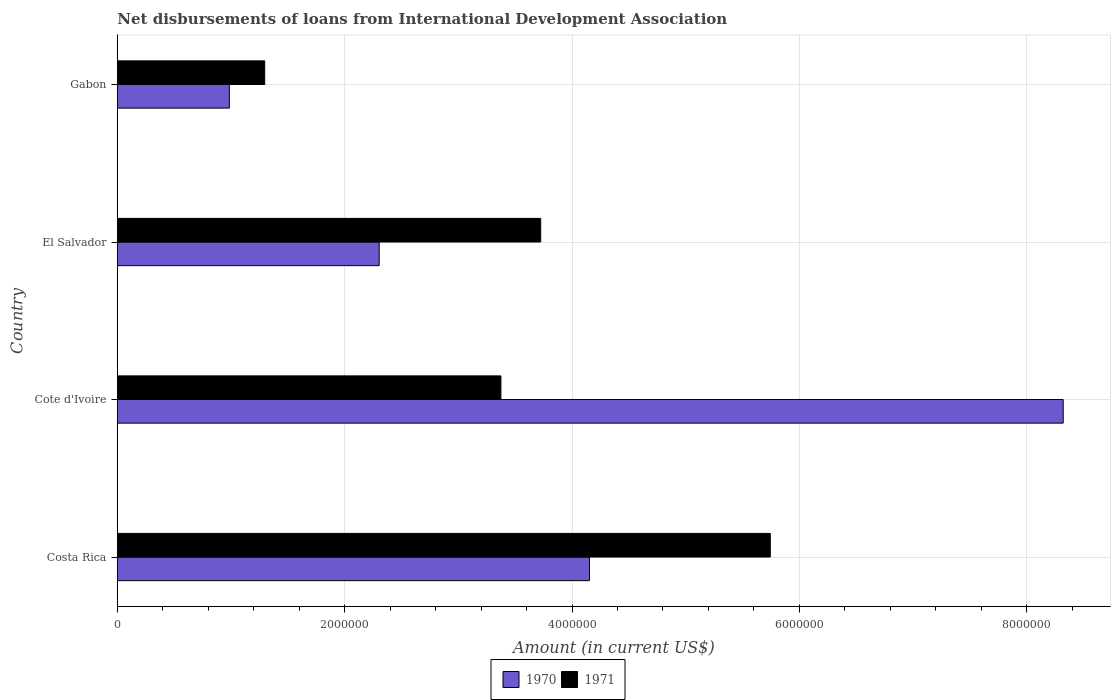How many different coloured bars are there?
Make the answer very short. 2. How many bars are there on the 1st tick from the top?
Provide a succinct answer. 2. How many bars are there on the 2nd tick from the bottom?
Provide a short and direct response. 2. In how many cases, is the number of bars for a given country not equal to the number of legend labels?
Keep it short and to the point. 0. What is the amount of loans disbursed in 1970 in Cote d'Ivoire?
Make the answer very short. 8.32e+06. Across all countries, what is the maximum amount of loans disbursed in 1970?
Your answer should be compact. 8.32e+06. Across all countries, what is the minimum amount of loans disbursed in 1970?
Ensure brevity in your answer.  9.85e+05. In which country was the amount of loans disbursed in 1970 maximum?
Give a very brief answer. Cote d'Ivoire. In which country was the amount of loans disbursed in 1971 minimum?
Make the answer very short. Gabon. What is the total amount of loans disbursed in 1970 in the graph?
Offer a very short reply. 1.58e+07. What is the difference between the amount of loans disbursed in 1970 in Cote d'Ivoire and that in Gabon?
Provide a short and direct response. 7.34e+06. What is the difference between the amount of loans disbursed in 1971 in Costa Rica and the amount of loans disbursed in 1970 in Cote d'Ivoire?
Your answer should be compact. -2.58e+06. What is the average amount of loans disbursed in 1971 per country?
Ensure brevity in your answer.  3.53e+06. What is the difference between the amount of loans disbursed in 1971 and amount of loans disbursed in 1970 in Cote d'Ivoire?
Give a very brief answer. -4.95e+06. What is the ratio of the amount of loans disbursed in 1970 in Costa Rica to that in Cote d'Ivoire?
Ensure brevity in your answer.  0.5. Is the amount of loans disbursed in 1971 in Costa Rica less than that in Gabon?
Make the answer very short. No. Is the difference between the amount of loans disbursed in 1971 in El Salvador and Gabon greater than the difference between the amount of loans disbursed in 1970 in El Salvador and Gabon?
Your response must be concise. Yes. What is the difference between the highest and the second highest amount of loans disbursed in 1970?
Offer a terse response. 4.17e+06. What is the difference between the highest and the lowest amount of loans disbursed in 1971?
Keep it short and to the point. 4.45e+06. In how many countries, is the amount of loans disbursed in 1971 greater than the average amount of loans disbursed in 1971 taken over all countries?
Make the answer very short. 2. What does the 2nd bar from the bottom in Cote d'Ivoire represents?
Make the answer very short. 1971. How many bars are there?
Offer a terse response. 8. How many countries are there in the graph?
Your response must be concise. 4. What is the difference between two consecutive major ticks on the X-axis?
Give a very brief answer. 2.00e+06. How are the legend labels stacked?
Ensure brevity in your answer.  Horizontal. What is the title of the graph?
Offer a terse response. Net disbursements of loans from International Development Association. Does "2007" appear as one of the legend labels in the graph?
Your answer should be very brief. No. What is the Amount (in current US$) of 1970 in Costa Rica?
Offer a terse response. 4.15e+06. What is the Amount (in current US$) of 1971 in Costa Rica?
Your response must be concise. 5.74e+06. What is the Amount (in current US$) in 1970 in Cote d'Ivoire?
Your answer should be compact. 8.32e+06. What is the Amount (in current US$) of 1971 in Cote d'Ivoire?
Ensure brevity in your answer.  3.37e+06. What is the Amount (in current US$) in 1970 in El Salvador?
Offer a terse response. 2.30e+06. What is the Amount (in current US$) in 1971 in El Salvador?
Ensure brevity in your answer.  3.72e+06. What is the Amount (in current US$) in 1970 in Gabon?
Offer a very short reply. 9.85e+05. What is the Amount (in current US$) in 1971 in Gabon?
Ensure brevity in your answer.  1.30e+06. Across all countries, what is the maximum Amount (in current US$) of 1970?
Provide a short and direct response. 8.32e+06. Across all countries, what is the maximum Amount (in current US$) of 1971?
Make the answer very short. 5.74e+06. Across all countries, what is the minimum Amount (in current US$) in 1970?
Ensure brevity in your answer.  9.85e+05. Across all countries, what is the minimum Amount (in current US$) in 1971?
Ensure brevity in your answer.  1.30e+06. What is the total Amount (in current US$) of 1970 in the graph?
Offer a terse response. 1.58e+07. What is the total Amount (in current US$) of 1971 in the graph?
Offer a terse response. 1.41e+07. What is the difference between the Amount (in current US$) in 1970 in Costa Rica and that in Cote d'Ivoire?
Provide a short and direct response. -4.17e+06. What is the difference between the Amount (in current US$) of 1971 in Costa Rica and that in Cote d'Ivoire?
Offer a very short reply. 2.37e+06. What is the difference between the Amount (in current US$) in 1970 in Costa Rica and that in El Salvador?
Give a very brief answer. 1.85e+06. What is the difference between the Amount (in current US$) of 1971 in Costa Rica and that in El Salvador?
Keep it short and to the point. 2.02e+06. What is the difference between the Amount (in current US$) of 1970 in Costa Rica and that in Gabon?
Provide a succinct answer. 3.17e+06. What is the difference between the Amount (in current US$) of 1971 in Costa Rica and that in Gabon?
Offer a very short reply. 4.45e+06. What is the difference between the Amount (in current US$) of 1970 in Cote d'Ivoire and that in El Salvador?
Keep it short and to the point. 6.02e+06. What is the difference between the Amount (in current US$) in 1971 in Cote d'Ivoire and that in El Salvador?
Offer a terse response. -3.50e+05. What is the difference between the Amount (in current US$) of 1970 in Cote d'Ivoire and that in Gabon?
Give a very brief answer. 7.34e+06. What is the difference between the Amount (in current US$) of 1971 in Cote d'Ivoire and that in Gabon?
Provide a succinct answer. 2.08e+06. What is the difference between the Amount (in current US$) of 1970 in El Salvador and that in Gabon?
Give a very brief answer. 1.32e+06. What is the difference between the Amount (in current US$) in 1971 in El Salvador and that in Gabon?
Offer a terse response. 2.43e+06. What is the difference between the Amount (in current US$) in 1970 in Costa Rica and the Amount (in current US$) in 1971 in Cote d'Ivoire?
Give a very brief answer. 7.79e+05. What is the difference between the Amount (in current US$) of 1970 in Costa Rica and the Amount (in current US$) of 1971 in El Salvador?
Give a very brief answer. 4.29e+05. What is the difference between the Amount (in current US$) of 1970 in Costa Rica and the Amount (in current US$) of 1971 in Gabon?
Offer a very short reply. 2.86e+06. What is the difference between the Amount (in current US$) of 1970 in Cote d'Ivoire and the Amount (in current US$) of 1971 in El Salvador?
Offer a very short reply. 4.60e+06. What is the difference between the Amount (in current US$) of 1970 in Cote d'Ivoire and the Amount (in current US$) of 1971 in Gabon?
Your answer should be compact. 7.02e+06. What is the difference between the Amount (in current US$) of 1970 in El Salvador and the Amount (in current US$) of 1971 in Gabon?
Your answer should be compact. 1.01e+06. What is the average Amount (in current US$) of 1970 per country?
Offer a very short reply. 3.94e+06. What is the average Amount (in current US$) of 1971 per country?
Offer a terse response. 3.53e+06. What is the difference between the Amount (in current US$) of 1970 and Amount (in current US$) of 1971 in Costa Rica?
Give a very brief answer. -1.59e+06. What is the difference between the Amount (in current US$) in 1970 and Amount (in current US$) in 1971 in Cote d'Ivoire?
Give a very brief answer. 4.95e+06. What is the difference between the Amount (in current US$) of 1970 and Amount (in current US$) of 1971 in El Salvador?
Ensure brevity in your answer.  -1.42e+06. What is the difference between the Amount (in current US$) in 1970 and Amount (in current US$) in 1971 in Gabon?
Give a very brief answer. -3.11e+05. What is the ratio of the Amount (in current US$) in 1970 in Costa Rica to that in Cote d'Ivoire?
Provide a succinct answer. 0.5. What is the ratio of the Amount (in current US$) of 1971 in Costa Rica to that in Cote d'Ivoire?
Ensure brevity in your answer.  1.7. What is the ratio of the Amount (in current US$) in 1970 in Costa Rica to that in El Salvador?
Offer a very short reply. 1.8. What is the ratio of the Amount (in current US$) of 1971 in Costa Rica to that in El Salvador?
Make the answer very short. 1.54. What is the ratio of the Amount (in current US$) in 1970 in Costa Rica to that in Gabon?
Provide a short and direct response. 4.22. What is the ratio of the Amount (in current US$) in 1971 in Costa Rica to that in Gabon?
Your response must be concise. 4.43. What is the ratio of the Amount (in current US$) of 1970 in Cote d'Ivoire to that in El Salvador?
Ensure brevity in your answer.  3.61. What is the ratio of the Amount (in current US$) in 1971 in Cote d'Ivoire to that in El Salvador?
Your response must be concise. 0.91. What is the ratio of the Amount (in current US$) of 1970 in Cote d'Ivoire to that in Gabon?
Your response must be concise. 8.45. What is the ratio of the Amount (in current US$) of 1971 in Cote d'Ivoire to that in Gabon?
Provide a succinct answer. 2.6. What is the ratio of the Amount (in current US$) of 1970 in El Salvador to that in Gabon?
Provide a succinct answer. 2.34. What is the ratio of the Amount (in current US$) of 1971 in El Salvador to that in Gabon?
Offer a terse response. 2.87. What is the difference between the highest and the second highest Amount (in current US$) in 1970?
Keep it short and to the point. 4.17e+06. What is the difference between the highest and the second highest Amount (in current US$) of 1971?
Give a very brief answer. 2.02e+06. What is the difference between the highest and the lowest Amount (in current US$) of 1970?
Offer a terse response. 7.34e+06. What is the difference between the highest and the lowest Amount (in current US$) in 1971?
Offer a very short reply. 4.45e+06. 